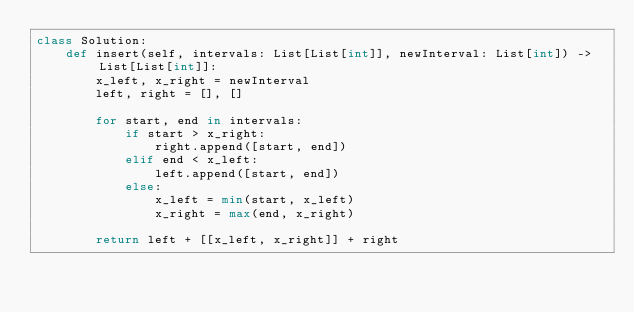<code> <loc_0><loc_0><loc_500><loc_500><_Python_>class Solution:
    def insert(self, intervals: List[List[int]], newInterval: List[int]) -> List[List[int]]:
        x_left, x_right = newInterval
        left, right = [], []

        for start, end in intervals:
            if start > x_right:
                right.append([start, end])
            elif end < x_left:
                left.append([start, end])
            else:
                x_left = min(start, x_left)
                x_right = max(end, x_right)

        return left + [[x_left, x_right]] + right
</code> 